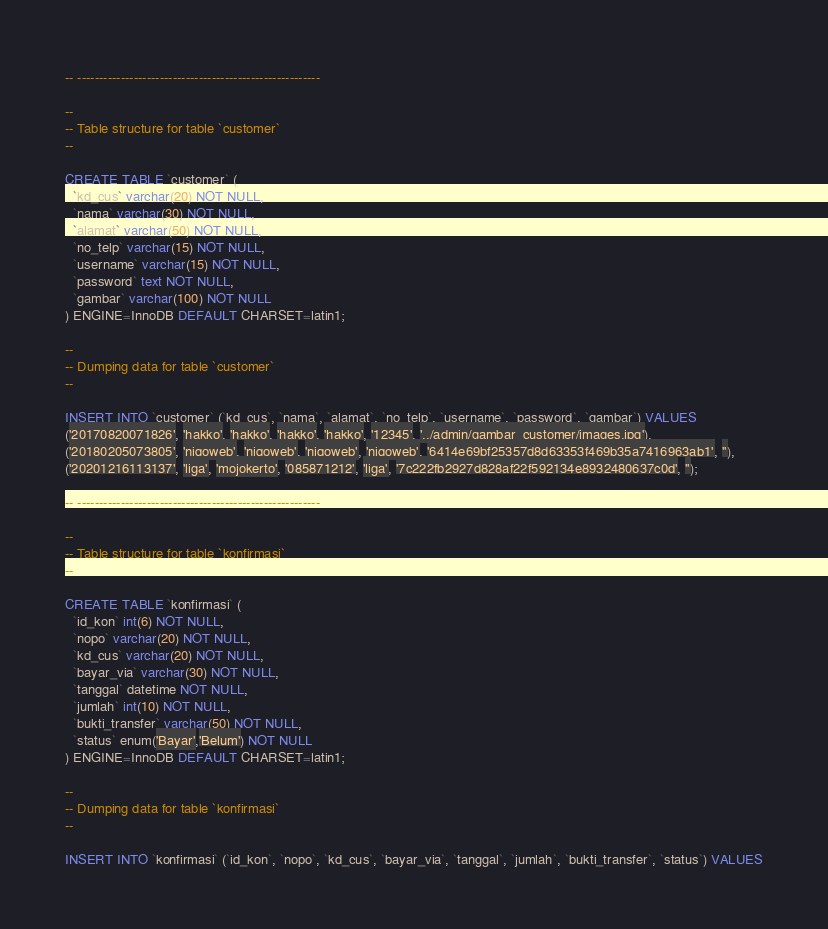Convert code to text. <code><loc_0><loc_0><loc_500><loc_500><_SQL_>-- --------------------------------------------------------

--
-- Table structure for table `customer`
--

CREATE TABLE `customer` (
  `kd_cus` varchar(20) NOT NULL,
  `nama` varchar(30) NOT NULL,
  `alamat` varchar(50) NOT NULL,
  `no_telp` varchar(15) NOT NULL,
  `username` varchar(15) NOT NULL,
  `password` text NOT NULL,
  `gambar` varchar(100) NOT NULL
) ENGINE=InnoDB DEFAULT CHARSET=latin1;

--
-- Dumping data for table `customer`
--

INSERT INTO `customer` (`kd_cus`, `nama`, `alamat`, `no_telp`, `username`, `password`, `gambar`) VALUES
('20170820071826', 'hakko', 'hakko', 'hakko', 'hakko', '12345', '../admin/gambar_customer/images.jpg'),
('20180205073805', 'niqoweb', 'niqoweb', 'niqoweb', 'niqoweb', '6414e69bf25357d8d63353f469b35a7416963ab1', ''),
('20201216113137', 'liga', 'mojokerto', '085871212', 'liga', '7c222fb2927d828af22f592134e8932480637c0d', '');

-- --------------------------------------------------------

--
-- Table structure for table `konfirmasi`
--

CREATE TABLE `konfirmasi` (
  `id_kon` int(6) NOT NULL,
  `nopo` varchar(20) NOT NULL,
  `kd_cus` varchar(20) NOT NULL,
  `bayar_via` varchar(30) NOT NULL,
  `tanggal` datetime NOT NULL,
  `jumlah` int(10) NOT NULL,
  `bukti_transfer` varchar(50) NOT NULL,
  `status` enum('Bayar','Belum') NOT NULL
) ENGINE=InnoDB DEFAULT CHARSET=latin1;

--
-- Dumping data for table `konfirmasi`
--

INSERT INTO `konfirmasi` (`id_kon`, `nopo`, `kd_cus`, `bayar_via`, `tanggal`, `jumlah`, `bukti_transfer`, `status`) VALUES</code> 